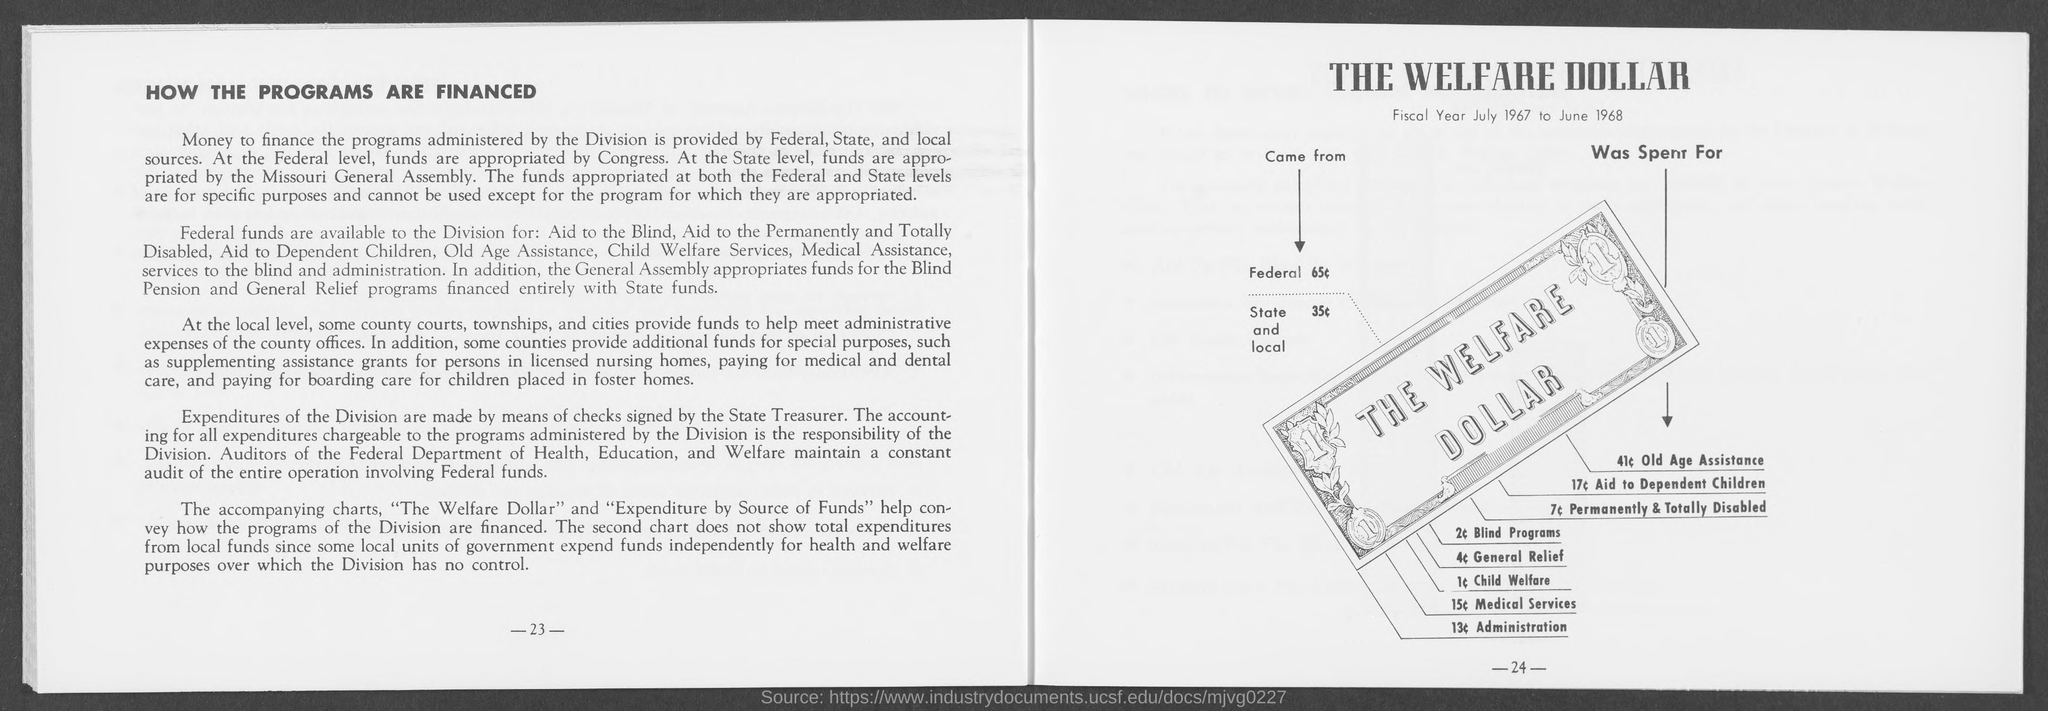What is the number at bottom- right side of the page ?
Your answer should be very brief. -24-. What is the number at bottom left side of the page ?
Ensure brevity in your answer.  23. 